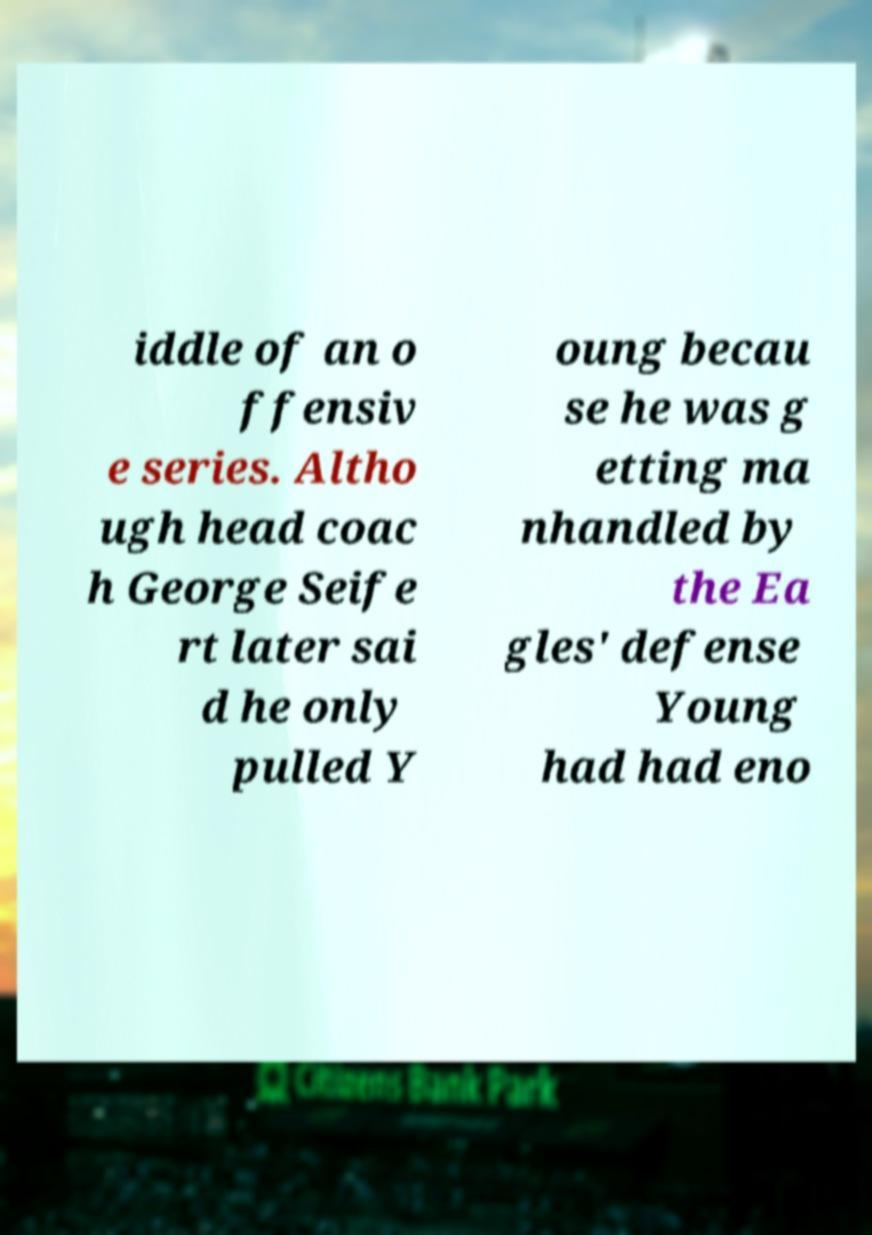I need the written content from this picture converted into text. Can you do that? iddle of an o ffensiv e series. Altho ugh head coac h George Seife rt later sai d he only pulled Y oung becau se he was g etting ma nhandled by the Ea gles' defense Young had had eno 